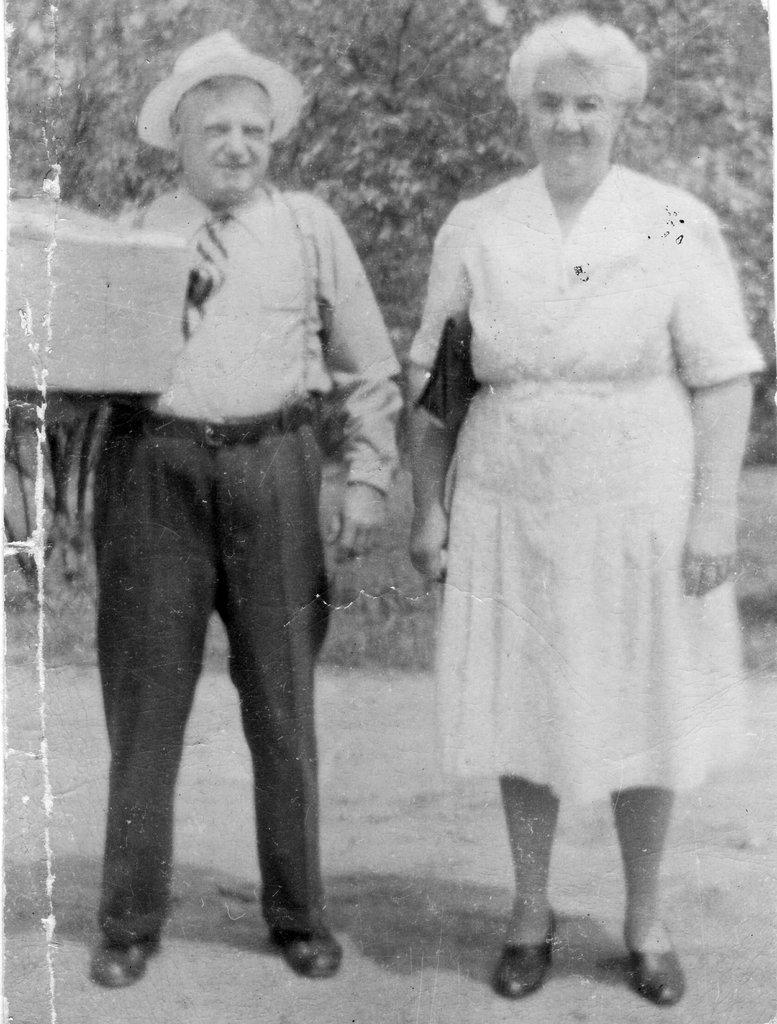Who are the people in the image? There is a man and a lady in the image. What are the man and the lady doing in the image? Both the man and the lady are standing in the image. What can be seen in the background of the image? There are trees in the background of the image. What type of quartz can be seen in the image? There is no quartz present in the image. How does the man push the lady in the image? The man does not push the lady in the image; they are both standing. 